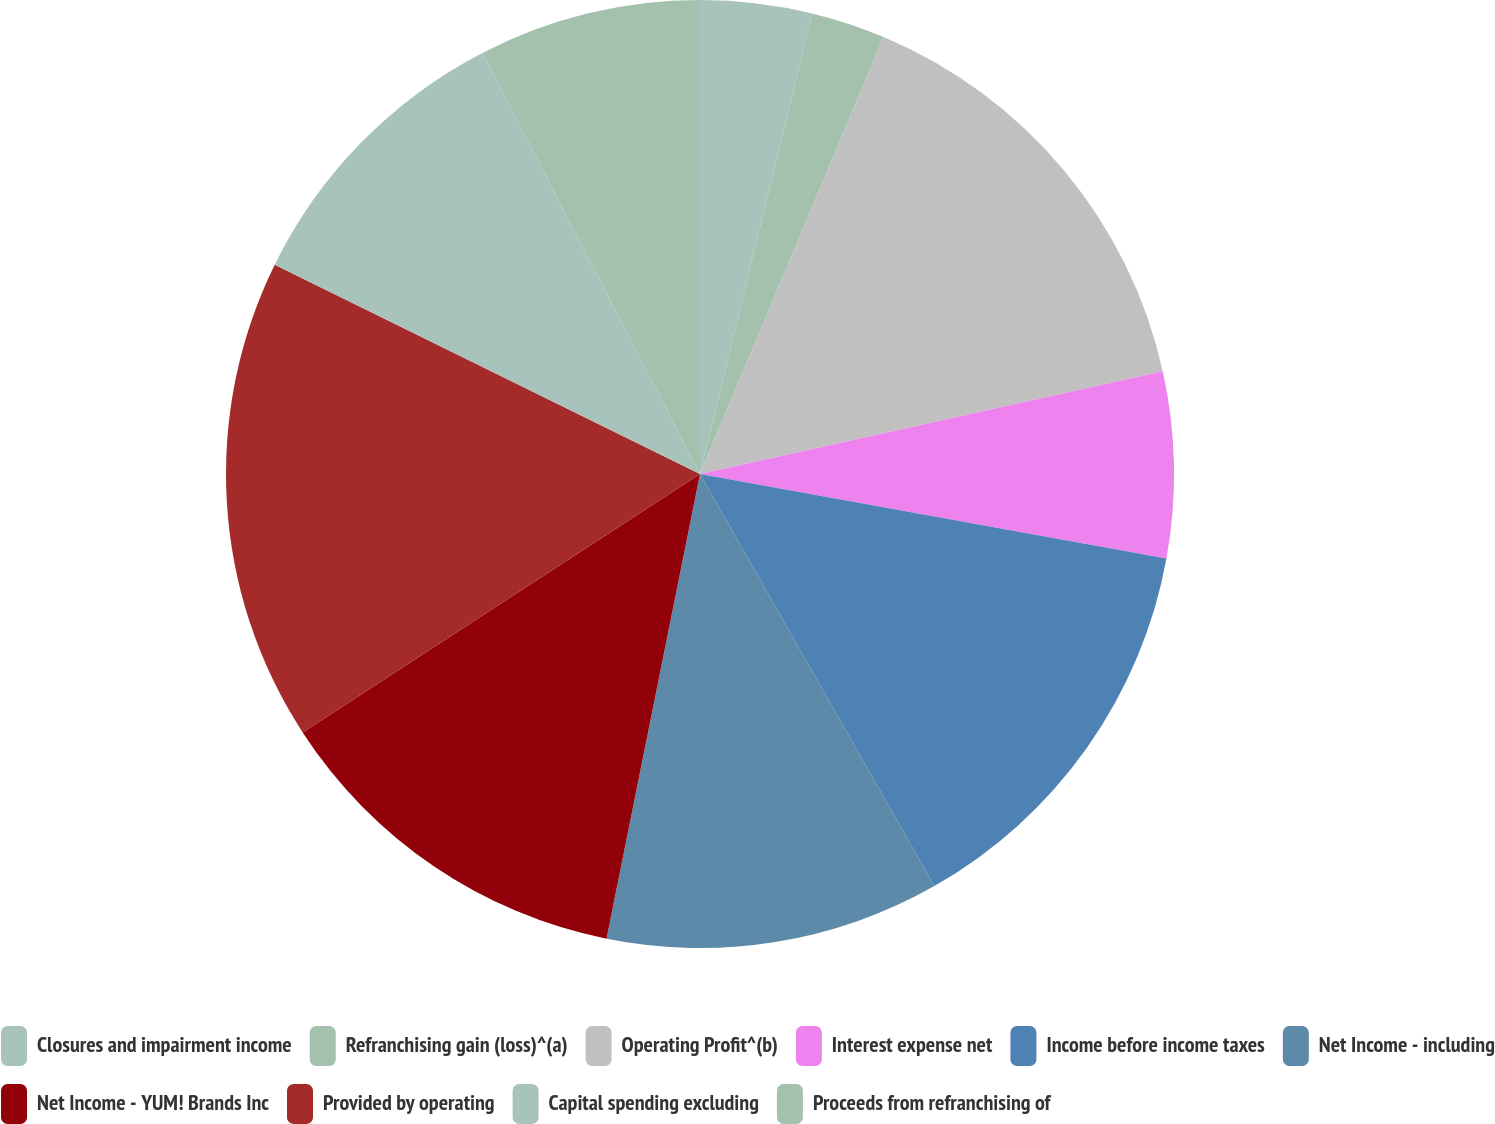Convert chart. <chart><loc_0><loc_0><loc_500><loc_500><pie_chart><fcel>Closures and impairment income<fcel>Refranchising gain (loss)^(a)<fcel>Operating Profit^(b)<fcel>Interest expense net<fcel>Income before income taxes<fcel>Net Income - including<fcel>Net Income - YUM! Brands Inc<fcel>Provided by operating<fcel>Capital spending excluding<fcel>Proceeds from refranchising of<nl><fcel>3.8%<fcel>2.53%<fcel>15.19%<fcel>6.33%<fcel>13.92%<fcel>11.39%<fcel>12.66%<fcel>16.46%<fcel>10.13%<fcel>7.59%<nl></chart> 